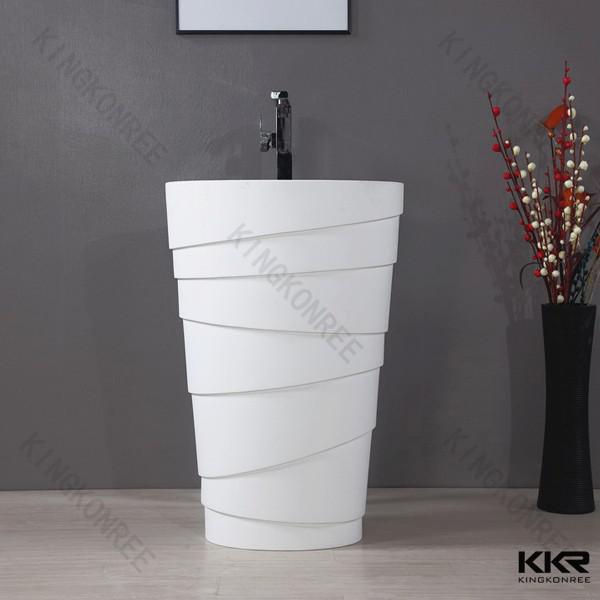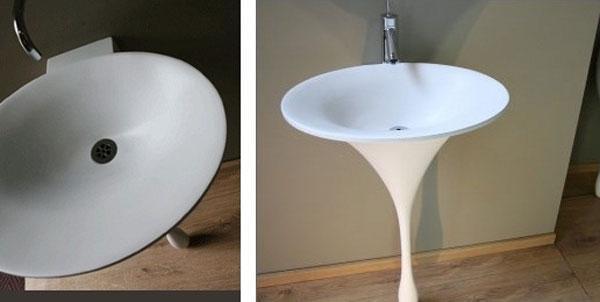The first image is the image on the left, the second image is the image on the right. Considering the images on both sides, is "The combined images include a white pedestal sink with a narrow, drop-like base, and a gooseneck spout over a rounded bowl-type sink." valid? Answer yes or no. Yes. 